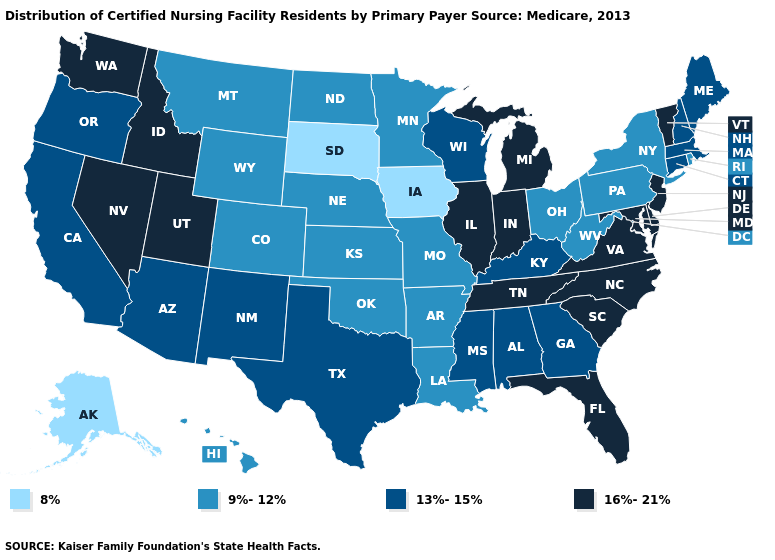Does Connecticut have a higher value than Wisconsin?
Concise answer only. No. Name the states that have a value in the range 13%-15%?
Write a very short answer. Alabama, Arizona, California, Connecticut, Georgia, Kentucky, Maine, Massachusetts, Mississippi, New Hampshire, New Mexico, Oregon, Texas, Wisconsin. What is the value of Oregon?
Answer briefly. 13%-15%. What is the value of Kentucky?
Answer briefly. 13%-15%. Name the states that have a value in the range 13%-15%?
Answer briefly. Alabama, Arizona, California, Connecticut, Georgia, Kentucky, Maine, Massachusetts, Mississippi, New Hampshire, New Mexico, Oregon, Texas, Wisconsin. Among the states that border Oregon , which have the highest value?
Keep it brief. Idaho, Nevada, Washington. What is the highest value in the MidWest ?
Quick response, please. 16%-21%. Does the map have missing data?
Concise answer only. No. Name the states that have a value in the range 8%?
Keep it brief. Alaska, Iowa, South Dakota. What is the lowest value in states that border New Hampshire?
Write a very short answer. 13%-15%. Name the states that have a value in the range 13%-15%?
Answer briefly. Alabama, Arizona, California, Connecticut, Georgia, Kentucky, Maine, Massachusetts, Mississippi, New Hampshire, New Mexico, Oregon, Texas, Wisconsin. What is the value of Maine?
Short answer required. 13%-15%. Does Arkansas have a higher value than Alaska?
Keep it brief. Yes. Among the states that border New Hampshire , does Vermont have the lowest value?
Quick response, please. No. Does the map have missing data?
Be succinct. No. 